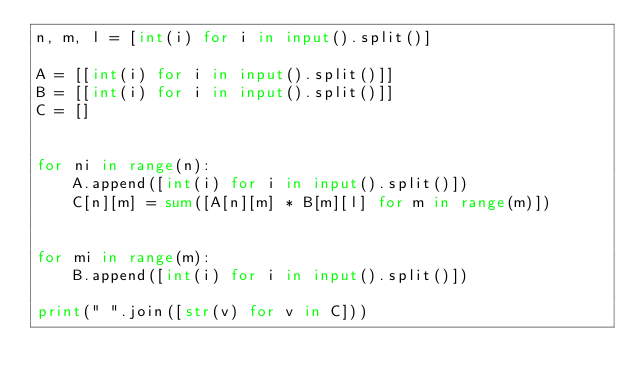Convert code to text. <code><loc_0><loc_0><loc_500><loc_500><_Python_>n, m, l = [int(i) for i in input().split()]

A = [[int(i) for i in input().split()]]
B = [[int(i) for i in input().split()]]
C = []


for ni in range(n):
    A.append([int(i) for i in input().split()])
    C[n][m] = sum([A[n][m] * B[m][l] for m in range(m)])


for mi in range(m):
    B.append([int(i) for i in input().split()])

print(" ".join([str(v) for v in C]))</code> 